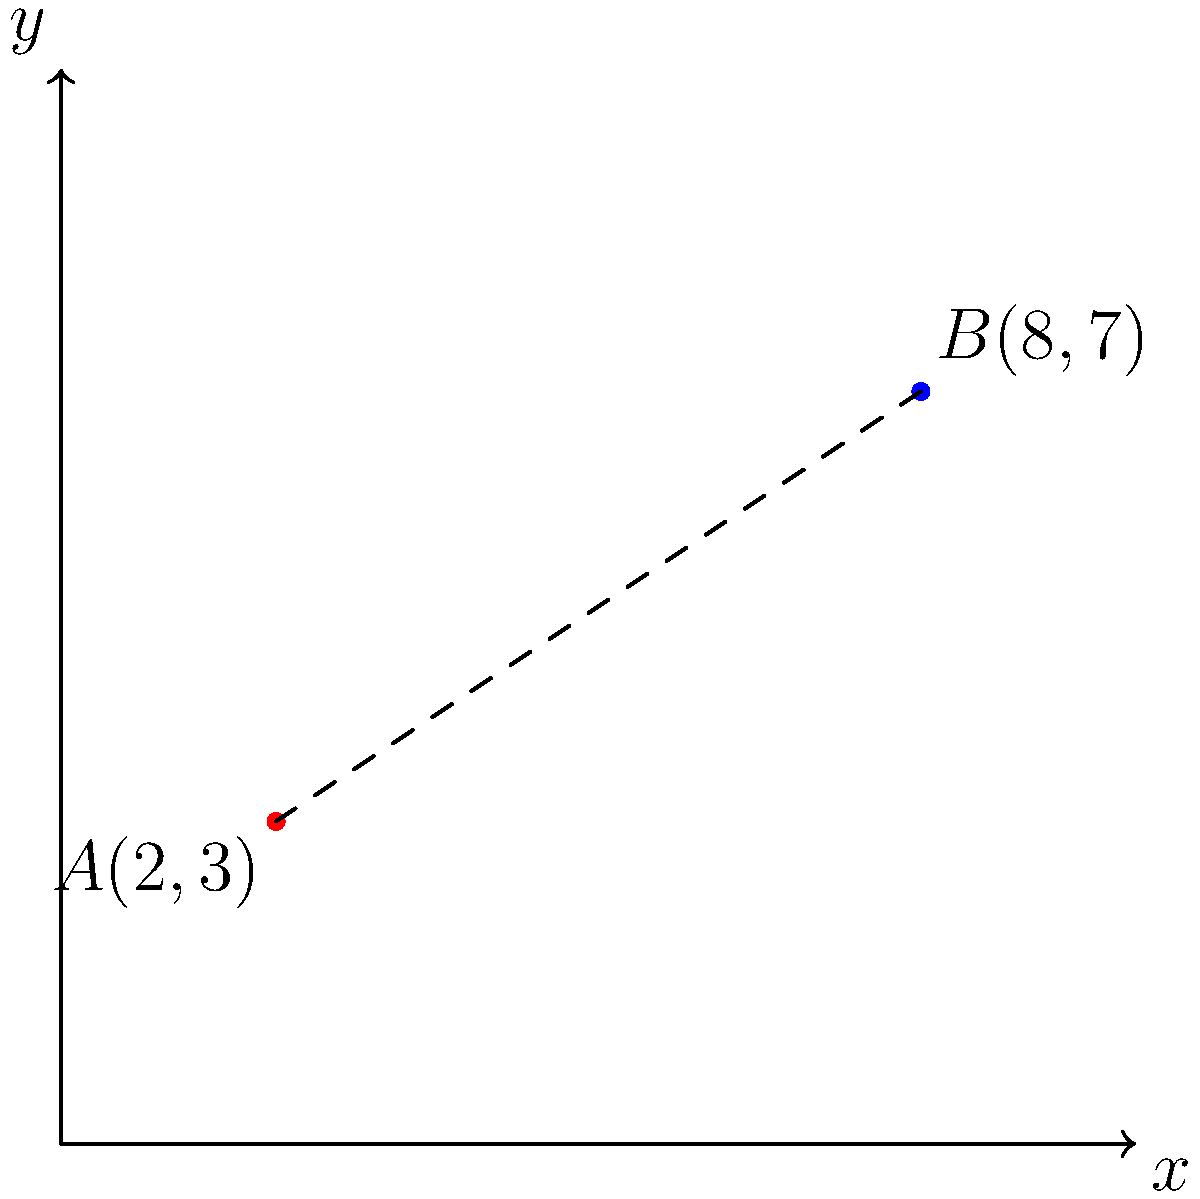A new surveillance device is being tested in a controlled environment. The device is placed at point $A(2,3)$ and needs to detect an object at point $B(8,7)$. What is the maximum range required for the surveillance device to successfully detect the object? Round your answer to two decimal places. To find the maximum range required for the surveillance device, we need to calculate the distance between points $A$ and $B$. We can use the distance formula derived from the Pythagorean theorem:

$$d = \sqrt{(x_2-x_1)^2 + (y_2-y_1)^2}$$

Where $(x_1,y_1)$ are the coordinates of point $A$ and $(x_2,y_2)$ are the coordinates of point $B$.

Step 1: Identify the coordinates
$A(x_1,y_1) = (2,3)$
$B(x_2,y_2) = (8,7)$

Step 2: Plug the coordinates into the distance formula
$$d = \sqrt{(8-2)^2 + (7-3)^2}$$

Step 3: Simplify the expressions inside the parentheses
$$d = \sqrt{6^2 + 4^2}$$

Step 4: Calculate the squares
$$d = \sqrt{36 + 16}$$

Step 5: Add the numbers under the square root
$$d = \sqrt{52}$$

Step 6: Calculate the square root and round to two decimal places
$$d \approx 7.21$$

Therefore, the maximum range required for the surveillance device to detect the object is approximately 7.21 units.
Answer: 7.21 units 